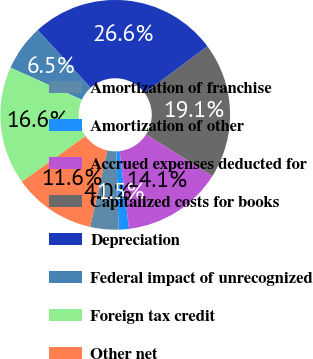Convert chart to OTSL. <chart><loc_0><loc_0><loc_500><loc_500><pie_chart><fcel>Amortization of franchise<fcel>Amortization of other<fcel>Accrued expenses deducted for<fcel>Capitalized costs for books<fcel>Depreciation<fcel>Federal impact of unrecognized<fcel>Foreign tax credit<fcel>Other net<nl><fcel>3.97%<fcel>1.45%<fcel>14.11%<fcel>19.14%<fcel>26.61%<fcel>6.48%<fcel>16.63%<fcel>11.6%<nl></chart> 